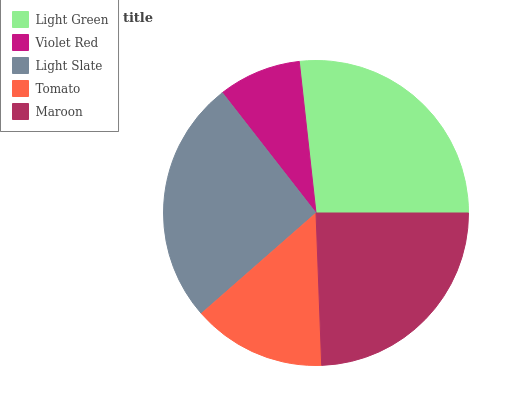Is Violet Red the minimum?
Answer yes or no. Yes. Is Light Green the maximum?
Answer yes or no. Yes. Is Light Slate the minimum?
Answer yes or no. No. Is Light Slate the maximum?
Answer yes or no. No. Is Light Slate greater than Violet Red?
Answer yes or no. Yes. Is Violet Red less than Light Slate?
Answer yes or no. Yes. Is Violet Red greater than Light Slate?
Answer yes or no. No. Is Light Slate less than Violet Red?
Answer yes or no. No. Is Maroon the high median?
Answer yes or no. Yes. Is Maroon the low median?
Answer yes or no. Yes. Is Light Green the high median?
Answer yes or no. No. Is Tomato the low median?
Answer yes or no. No. 